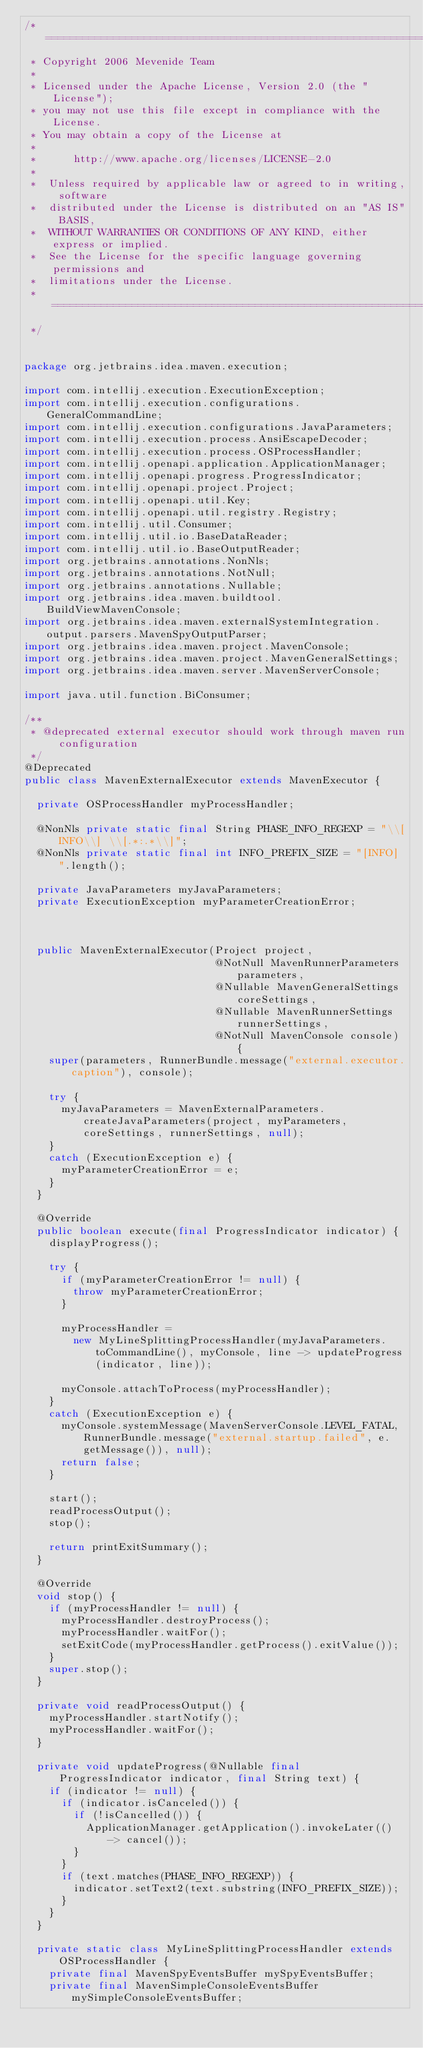Convert code to text. <code><loc_0><loc_0><loc_500><loc_500><_Java_>/* ==========================================================================
 * Copyright 2006 Mevenide Team
 *
 * Licensed under the Apache License, Version 2.0 (the "License");
 * you may not use this file except in compliance with the License.
 * You may obtain a copy of the License at
 *
 *      http://www.apache.org/licenses/LICENSE-2.0
 *
 *  Unless required by applicable law or agreed to in writing, software
 *  distributed under the License is distributed on an "AS IS" BASIS,
 *  WITHOUT WARRANTIES OR CONDITIONS OF ANY KIND, either express or implied.
 *  See the License for the specific language governing permissions and
 *  limitations under the License.
 * =========================================================================
 */


package org.jetbrains.idea.maven.execution;

import com.intellij.execution.ExecutionException;
import com.intellij.execution.configurations.GeneralCommandLine;
import com.intellij.execution.configurations.JavaParameters;
import com.intellij.execution.process.AnsiEscapeDecoder;
import com.intellij.execution.process.OSProcessHandler;
import com.intellij.openapi.application.ApplicationManager;
import com.intellij.openapi.progress.ProgressIndicator;
import com.intellij.openapi.project.Project;
import com.intellij.openapi.util.Key;
import com.intellij.openapi.util.registry.Registry;
import com.intellij.util.Consumer;
import com.intellij.util.io.BaseDataReader;
import com.intellij.util.io.BaseOutputReader;
import org.jetbrains.annotations.NonNls;
import org.jetbrains.annotations.NotNull;
import org.jetbrains.annotations.Nullable;
import org.jetbrains.idea.maven.buildtool.BuildViewMavenConsole;
import org.jetbrains.idea.maven.externalSystemIntegration.output.parsers.MavenSpyOutputParser;
import org.jetbrains.idea.maven.project.MavenConsole;
import org.jetbrains.idea.maven.project.MavenGeneralSettings;
import org.jetbrains.idea.maven.server.MavenServerConsole;

import java.util.function.BiConsumer;

/**
 * @deprecated external executor should work through maven run configuration
 */
@Deprecated
public class MavenExternalExecutor extends MavenExecutor {

  private OSProcessHandler myProcessHandler;

  @NonNls private static final String PHASE_INFO_REGEXP = "\\[INFO\\] \\[.*:.*\\]";
  @NonNls private static final int INFO_PREFIX_SIZE = "[INFO] ".length();

  private JavaParameters myJavaParameters;
  private ExecutionException myParameterCreationError;



  public MavenExternalExecutor(Project project,
                               @NotNull MavenRunnerParameters parameters,
                               @Nullable MavenGeneralSettings coreSettings,
                               @Nullable MavenRunnerSettings runnerSettings,
                               @NotNull MavenConsole console) {
    super(parameters, RunnerBundle.message("external.executor.caption"), console);

    try {
      myJavaParameters = MavenExternalParameters.createJavaParameters(project, myParameters, coreSettings, runnerSettings, null);
    }
    catch (ExecutionException e) {
      myParameterCreationError = e;
    }
  }

  @Override
  public boolean execute(final ProgressIndicator indicator) {
    displayProgress();

    try {
      if (myParameterCreationError != null) {
        throw myParameterCreationError;
      }

      myProcessHandler =
        new MyLineSplittingProcessHandler(myJavaParameters.toCommandLine(), myConsole, line -> updateProgress(indicator, line));

      myConsole.attachToProcess(myProcessHandler);
    }
    catch (ExecutionException e) {
      myConsole.systemMessage(MavenServerConsole.LEVEL_FATAL, RunnerBundle.message("external.startup.failed", e.getMessage()), null);
      return false;
    }

    start();
    readProcessOutput();
    stop();

    return printExitSummary();
  }

  @Override
  void stop() {
    if (myProcessHandler != null) {
      myProcessHandler.destroyProcess();
      myProcessHandler.waitFor();
      setExitCode(myProcessHandler.getProcess().exitValue());
    }
    super.stop();
  }

  private void readProcessOutput() {
    myProcessHandler.startNotify();
    myProcessHandler.waitFor();
  }

  private void updateProgress(@Nullable final ProgressIndicator indicator, final String text) {
    if (indicator != null) {
      if (indicator.isCanceled()) {
        if (!isCancelled()) {
          ApplicationManager.getApplication().invokeLater(() -> cancel());
        }
      }
      if (text.matches(PHASE_INFO_REGEXP)) {
        indicator.setText2(text.substring(INFO_PREFIX_SIZE));
      }
    }
  }

  private static class MyLineSplittingProcessHandler extends OSProcessHandler {
    private final MavenSpyEventsBuffer mySpyEventsBuffer;
    private final MavenSimpleConsoleEventsBuffer mySimpleConsoleEventsBuffer;</code> 